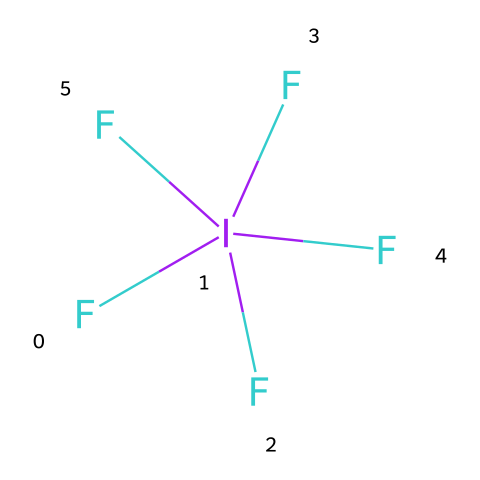How many fluorine atoms are present in iodine pentafluoride? The SMILES representation shows five fluorine atoms connected to one iodine atom, indicating a total of five fluorine atoms.
Answer: five What is the central atom in the molecular structure of iodine pentafluoride? The chemical structure indicates that iodine is the central atom as it is surrounded by the five fluorine atoms.
Answer: iodine What is the oxidation state of iodine in iodine pentafluoride? In this compound, iodine is bonded to five fluorine atoms, each contributing a -1 oxidation state, indicating that iodine has an oxidation state of +5.
Answer: +5 What type of molecular geometry does iodine pentafluoride exhibit? Iodine pentafluoride has a square pyramidal geometry due to the arrangement of five bonding pairs of electrons around the iodine atom.
Answer: square pyramidal Why is iodine pentafluoride considered a strong oxidizing agent? The highly electronegative fluorine atoms create a strong tendency for the iodine atom to accept electrons, making it an effective oxidizing agent.
Answer: strong oxidizing agent What is the hybridization of iodine in iodine pentafluoride? The presence of five bonding pairs around the iodine atom suggests that it undergoes sp3d hybridization to accommodate the molecular geometry.
Answer: sp3d 